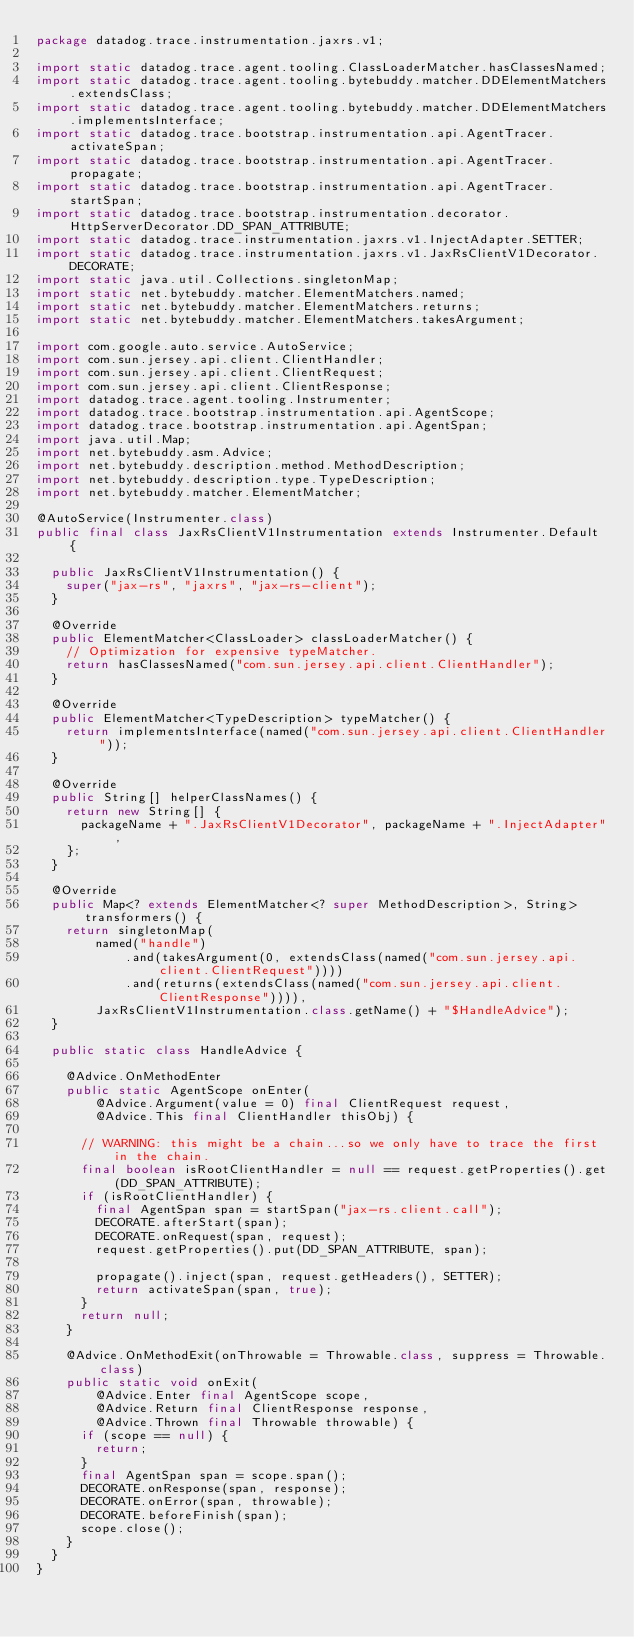<code> <loc_0><loc_0><loc_500><loc_500><_Java_>package datadog.trace.instrumentation.jaxrs.v1;

import static datadog.trace.agent.tooling.ClassLoaderMatcher.hasClassesNamed;
import static datadog.trace.agent.tooling.bytebuddy.matcher.DDElementMatchers.extendsClass;
import static datadog.trace.agent.tooling.bytebuddy.matcher.DDElementMatchers.implementsInterface;
import static datadog.trace.bootstrap.instrumentation.api.AgentTracer.activateSpan;
import static datadog.trace.bootstrap.instrumentation.api.AgentTracer.propagate;
import static datadog.trace.bootstrap.instrumentation.api.AgentTracer.startSpan;
import static datadog.trace.bootstrap.instrumentation.decorator.HttpServerDecorator.DD_SPAN_ATTRIBUTE;
import static datadog.trace.instrumentation.jaxrs.v1.InjectAdapter.SETTER;
import static datadog.trace.instrumentation.jaxrs.v1.JaxRsClientV1Decorator.DECORATE;
import static java.util.Collections.singletonMap;
import static net.bytebuddy.matcher.ElementMatchers.named;
import static net.bytebuddy.matcher.ElementMatchers.returns;
import static net.bytebuddy.matcher.ElementMatchers.takesArgument;

import com.google.auto.service.AutoService;
import com.sun.jersey.api.client.ClientHandler;
import com.sun.jersey.api.client.ClientRequest;
import com.sun.jersey.api.client.ClientResponse;
import datadog.trace.agent.tooling.Instrumenter;
import datadog.trace.bootstrap.instrumentation.api.AgentScope;
import datadog.trace.bootstrap.instrumentation.api.AgentSpan;
import java.util.Map;
import net.bytebuddy.asm.Advice;
import net.bytebuddy.description.method.MethodDescription;
import net.bytebuddy.description.type.TypeDescription;
import net.bytebuddy.matcher.ElementMatcher;

@AutoService(Instrumenter.class)
public final class JaxRsClientV1Instrumentation extends Instrumenter.Default {

  public JaxRsClientV1Instrumentation() {
    super("jax-rs", "jaxrs", "jax-rs-client");
  }

  @Override
  public ElementMatcher<ClassLoader> classLoaderMatcher() {
    // Optimization for expensive typeMatcher.
    return hasClassesNamed("com.sun.jersey.api.client.ClientHandler");
  }

  @Override
  public ElementMatcher<TypeDescription> typeMatcher() {
    return implementsInterface(named("com.sun.jersey.api.client.ClientHandler"));
  }

  @Override
  public String[] helperClassNames() {
    return new String[] {
      packageName + ".JaxRsClientV1Decorator", packageName + ".InjectAdapter",
    };
  }

  @Override
  public Map<? extends ElementMatcher<? super MethodDescription>, String> transformers() {
    return singletonMap(
        named("handle")
            .and(takesArgument(0, extendsClass(named("com.sun.jersey.api.client.ClientRequest"))))
            .and(returns(extendsClass(named("com.sun.jersey.api.client.ClientResponse")))),
        JaxRsClientV1Instrumentation.class.getName() + "$HandleAdvice");
  }

  public static class HandleAdvice {

    @Advice.OnMethodEnter
    public static AgentScope onEnter(
        @Advice.Argument(value = 0) final ClientRequest request,
        @Advice.This final ClientHandler thisObj) {

      // WARNING: this might be a chain...so we only have to trace the first in the chain.
      final boolean isRootClientHandler = null == request.getProperties().get(DD_SPAN_ATTRIBUTE);
      if (isRootClientHandler) {
        final AgentSpan span = startSpan("jax-rs.client.call");
        DECORATE.afterStart(span);
        DECORATE.onRequest(span, request);
        request.getProperties().put(DD_SPAN_ATTRIBUTE, span);

        propagate().inject(span, request.getHeaders(), SETTER);
        return activateSpan(span, true);
      }
      return null;
    }

    @Advice.OnMethodExit(onThrowable = Throwable.class, suppress = Throwable.class)
    public static void onExit(
        @Advice.Enter final AgentScope scope,
        @Advice.Return final ClientResponse response,
        @Advice.Thrown final Throwable throwable) {
      if (scope == null) {
        return;
      }
      final AgentSpan span = scope.span();
      DECORATE.onResponse(span, response);
      DECORATE.onError(span, throwable);
      DECORATE.beforeFinish(span);
      scope.close();
    }
  }
}
</code> 